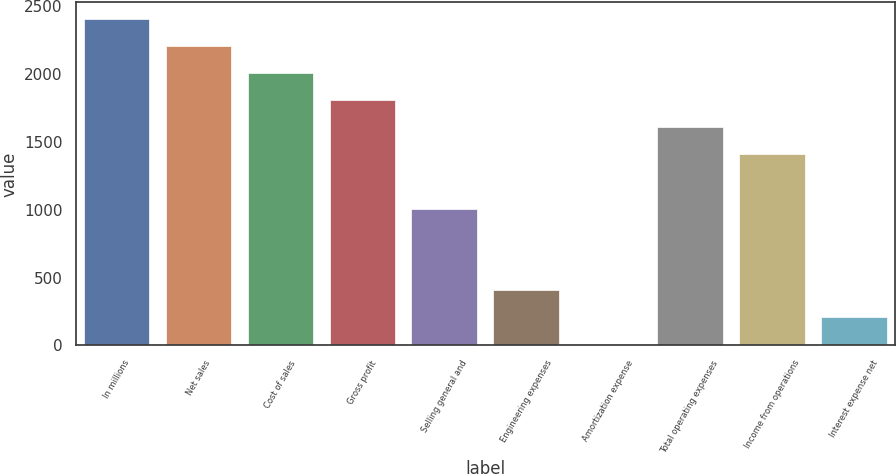Convert chart to OTSL. <chart><loc_0><loc_0><loc_500><loc_500><bar_chart><fcel>In millions<fcel>Net sales<fcel>Cost of sales<fcel>Gross profit<fcel>Selling general and<fcel>Engineering expenses<fcel>Amortization expense<fcel>Total operating expenses<fcel>Income from operations<fcel>Interest expense net<nl><fcel>2408.82<fcel>2208.91<fcel>2009<fcel>1809.09<fcel>1009.45<fcel>409.72<fcel>9.9<fcel>1609.18<fcel>1409.27<fcel>209.81<nl></chart> 